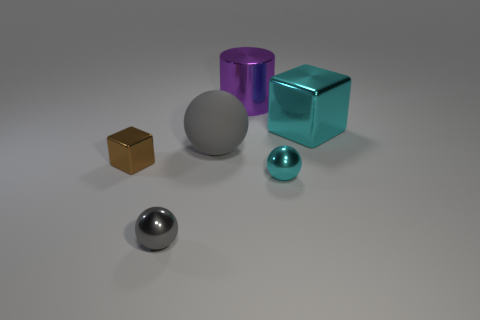Do the cyan sphere and the metallic cube that is behind the large matte ball have the same size?
Provide a short and direct response. No. What color is the ball that is on the left side of the large metallic cylinder and right of the tiny gray shiny sphere?
Make the answer very short. Gray. How many other objects are the same shape as the large cyan metal thing?
Make the answer very short. 1. Is the color of the metal block that is on the right side of the brown thing the same as the small metallic thing that is on the right side of the gray rubber sphere?
Keep it short and to the point. Yes. There is a gray thing that is right of the small gray sphere; is it the same size as the cyan thing that is right of the small cyan metal ball?
Make the answer very short. Yes. Is there any other thing that has the same material as the large gray thing?
Give a very brief answer. No. What material is the gray object behind the cyan object in front of the brown shiny block that is left of the big rubber ball?
Make the answer very short. Rubber. Is the gray shiny thing the same shape as the gray rubber object?
Make the answer very short. Yes. There is a cyan object that is the same shape as the brown object; what material is it?
Provide a short and direct response. Metal. What number of small things have the same color as the large ball?
Your response must be concise. 1. 